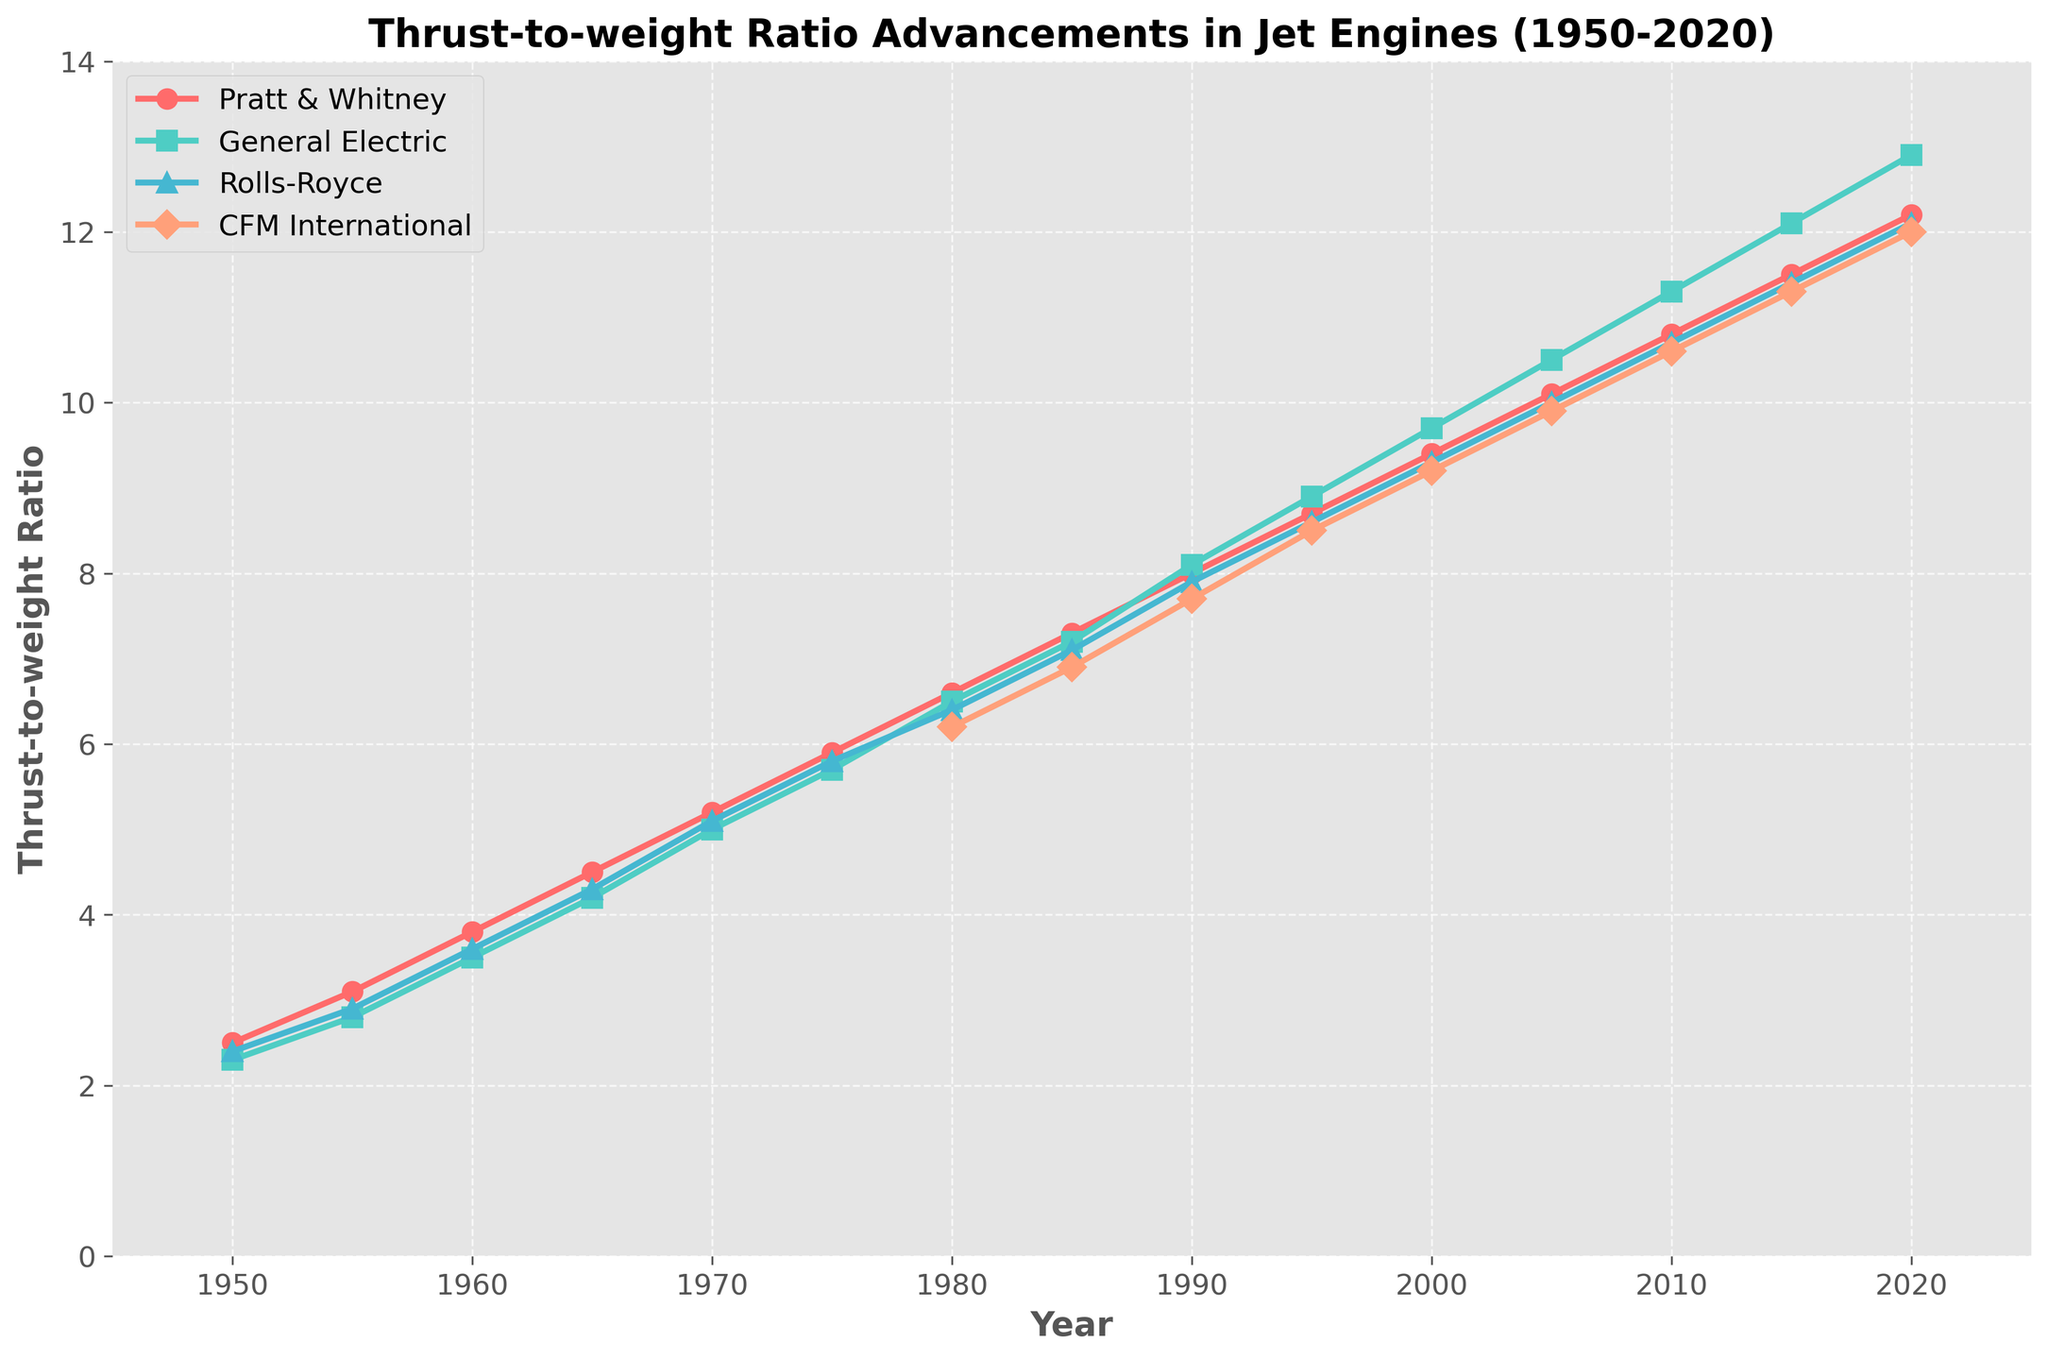What is the trend of the thrust-to-weight ratio for Pratt & Whitney from 1950 to 2020? To determine the trend, examine the plotted line for Pratt & Whitney from 1950 to 2020. The line shows a consistent upward trajectory over time, indicating continuous improvement.
Answer: Upward trend Which manufacturer had the highest thrust-to-weight ratio in 2020? Look at the values at the endpoint (2020) for each manufacturer. General Electric's line is the highest, indicating that it had the highest thrust-to-weight ratio.
Answer: General Electric Between which years did General Electric surpass Pratt & Whitney in thrust-to-weight ratio? Observe the point where the General Electric line crosses and stays above the Pratt & Whitney line. This occurs between 1980 and 1990.
Answer: Between 1980 and 1990 What is the average thrust-to-weight ratio for Rolls-Royce in the period 2000-2020? Sum the values for Rolls-Royce in the years 2000, 2005, 2010, 2015, and 2020 and divide by the number of data points: (9.3 + 10.0 + 10.7 + 11.4 + 12.1) / 5.
Answer: 10.7 Which two manufacturers had the closest thrust-to-weight ratios in 1990? Compare the values for all manufacturers in 1990. Pratt & Whitney and Rolls-Royce had very close values (8.0 vs. 7.9).
Answer: Pratt & Whitney and Rolls-Royce By how much did the thrust-to-weight ratio for CFM International improve from 1980 to 2020? Subtract the 1980 value from the 2020 value for CFM International: 12.0 - 6.2.
Answer: 5.8 What visual feature distinguishes the different manufacturers' lines? Each manufacturer's line has unique visual attributes: different colors and different marker shapes (e.g., circles, squares, triangles, diamonds).
Answer: Color and marker shape Which manufacturer had the slowest improvement rate from 1950 to 2000? Assess the slope of each line over the period from 1950 to 2000. CFM International shows the least improvement, as its line is the flattest on average.
Answer: CFM International Does any manufacturer show a decrease in thrust-to-weight ratio at any point throughout the timeline? Check each manufacturer's line for any downward slopes. All lines show a continuous increase, with no decreases.
Answer: No 